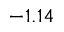Convert formula to latex. <formula><loc_0><loc_0><loc_500><loc_500>- 1 . 1 4</formula> 